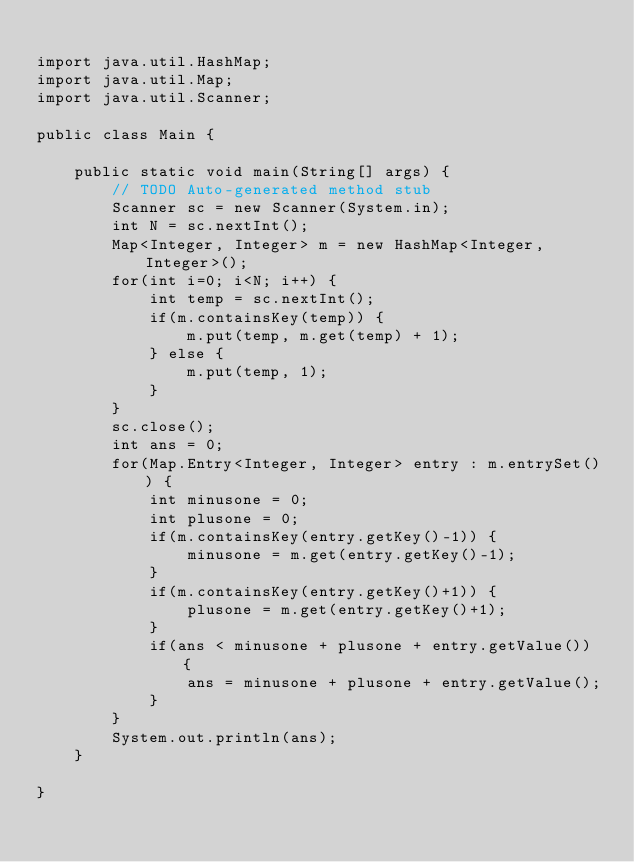<code> <loc_0><loc_0><loc_500><loc_500><_Java_>
import java.util.HashMap;
import java.util.Map;
import java.util.Scanner;

public class Main {

	public static void main(String[] args) {
		// TODO Auto-generated method stub
		Scanner sc = new Scanner(System.in);
		int N = sc.nextInt();
		Map<Integer, Integer> m = new HashMap<Integer, Integer>();
		for(int i=0; i<N; i++) {
			int temp = sc.nextInt();
			if(m.containsKey(temp)) {
				m.put(temp, m.get(temp) + 1);
			} else {
				m.put(temp, 1);
			}
		}
		sc.close();
		int ans = 0;
		for(Map.Entry<Integer, Integer> entry : m.entrySet()) {
			int minusone = 0;
			int plusone = 0;
			if(m.containsKey(entry.getKey()-1)) {
				minusone = m.get(entry.getKey()-1);
			}
			if(m.containsKey(entry.getKey()+1)) {
				plusone = m.get(entry.getKey()+1);
			}
			if(ans < minusone + plusone + entry.getValue()) {
				ans = minusone + plusone + entry.getValue();
			}
		}
		System.out.println(ans);
	}

}
</code> 